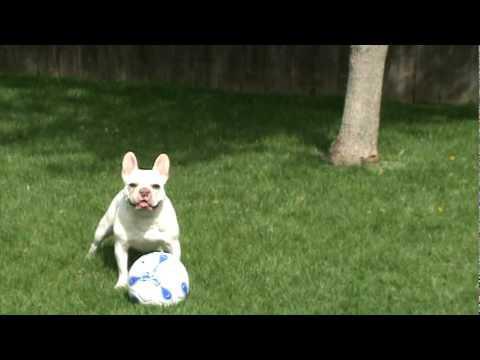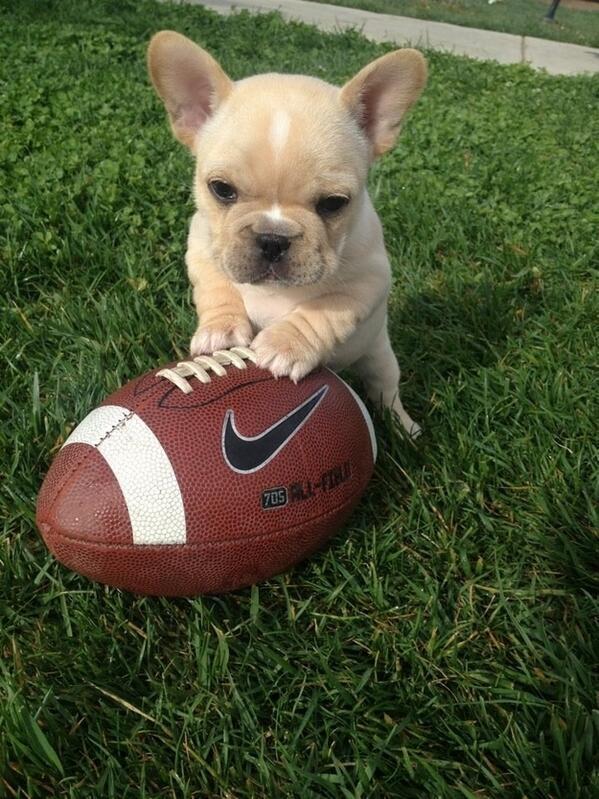The first image is the image on the left, the second image is the image on the right. Evaluate the accuracy of this statement regarding the images: "The dog in the image on the right is playing with a yellow ball.". Is it true? Answer yes or no. No. The first image is the image on the left, the second image is the image on the right. Assess this claim about the two images: "An image shows a brown dog playing with a yellow tennis ball in an area with green ground.". Correct or not? Answer yes or no. No. 